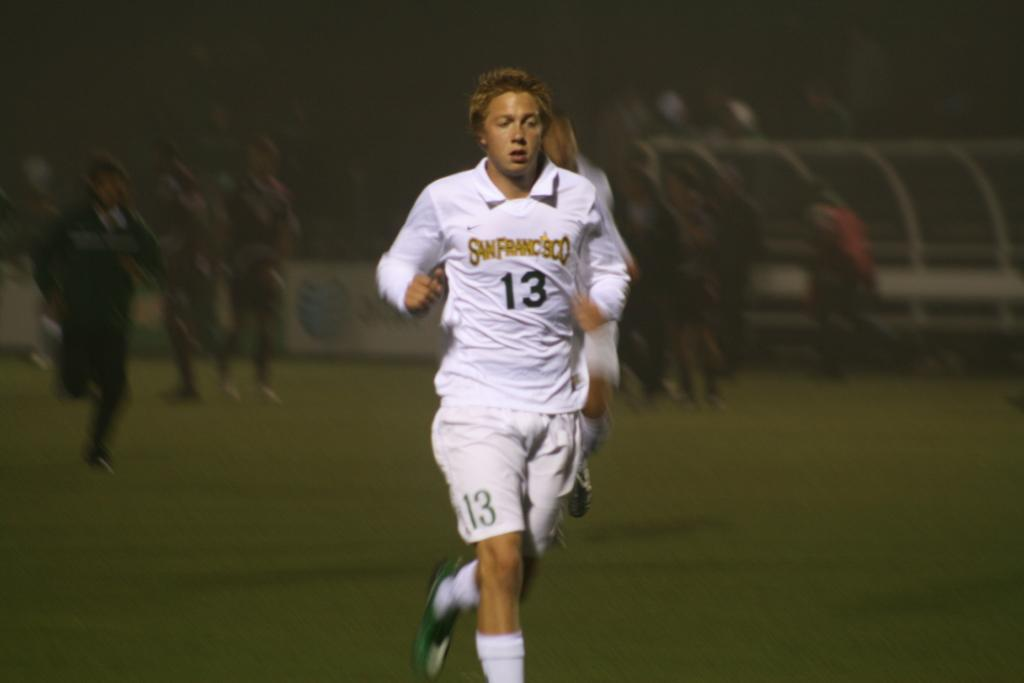<image>
Share a concise interpretation of the image provided. A woman wearing a number 13 shirt who is running on a field. 